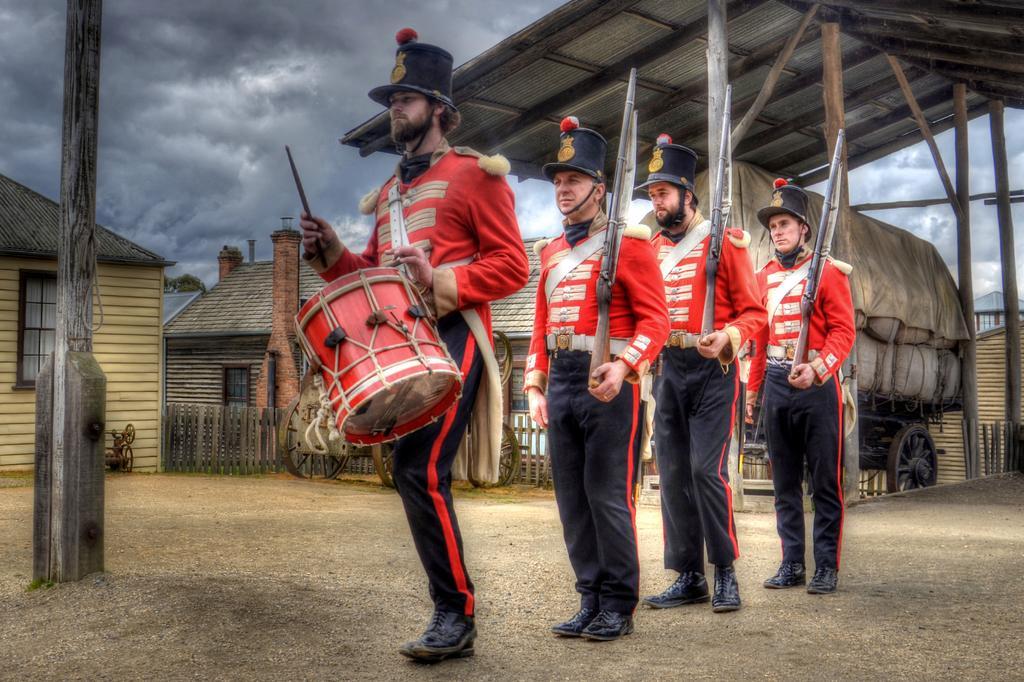Please provide a concise description of this image. There are four men here. The first person is playing drum,behind him there are three people holding gun in their hand. In the background there are houses,vehicle and cloudy sky. 